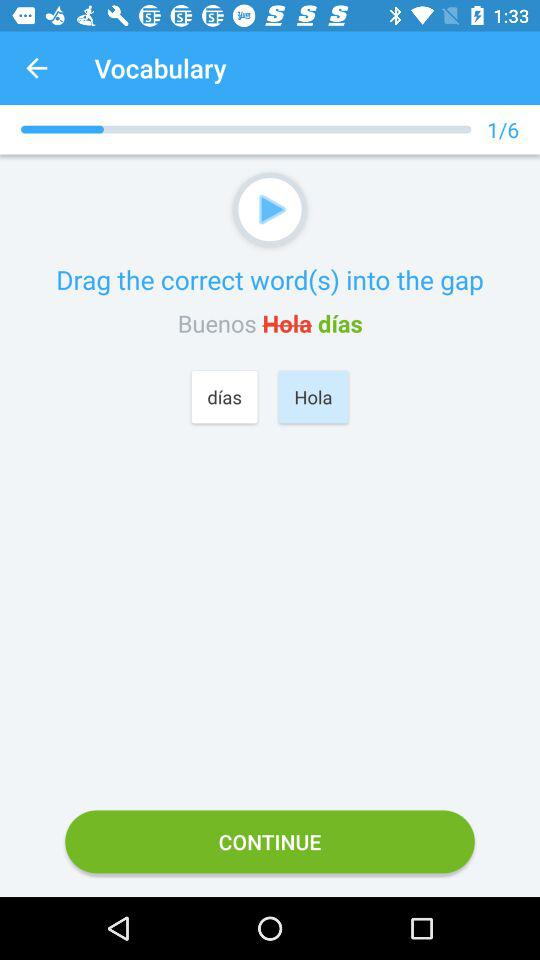At which question am I? You are the first question. 